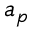Convert formula to latex. <formula><loc_0><loc_0><loc_500><loc_500>a _ { p }</formula> 